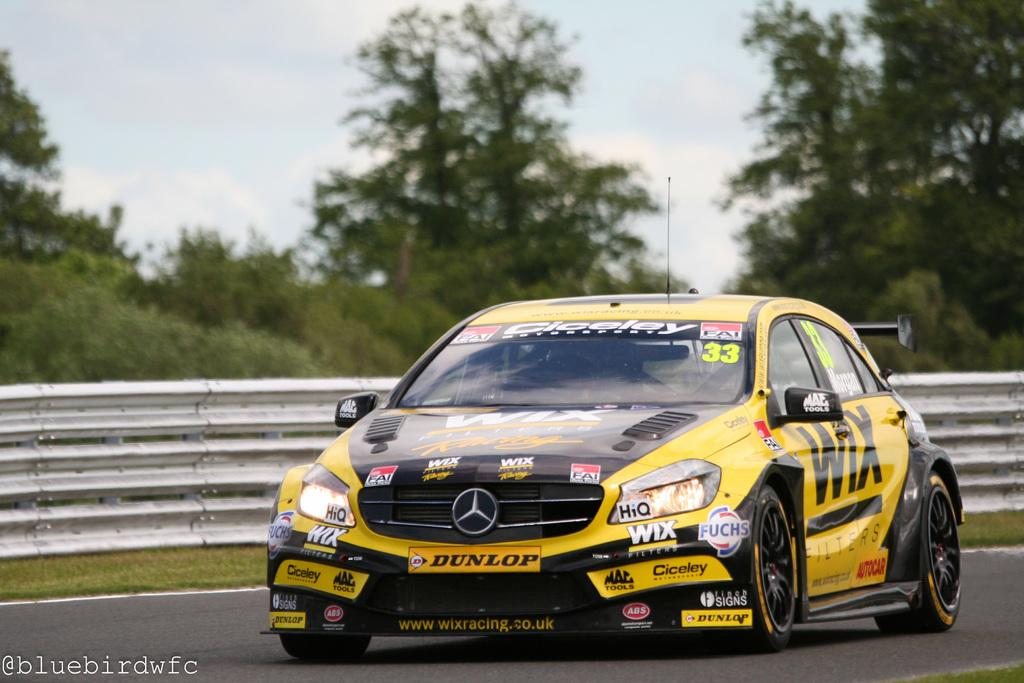<image>
Write a terse but informative summary of the picture. The yellow car has a WIX banner on the front fender. 